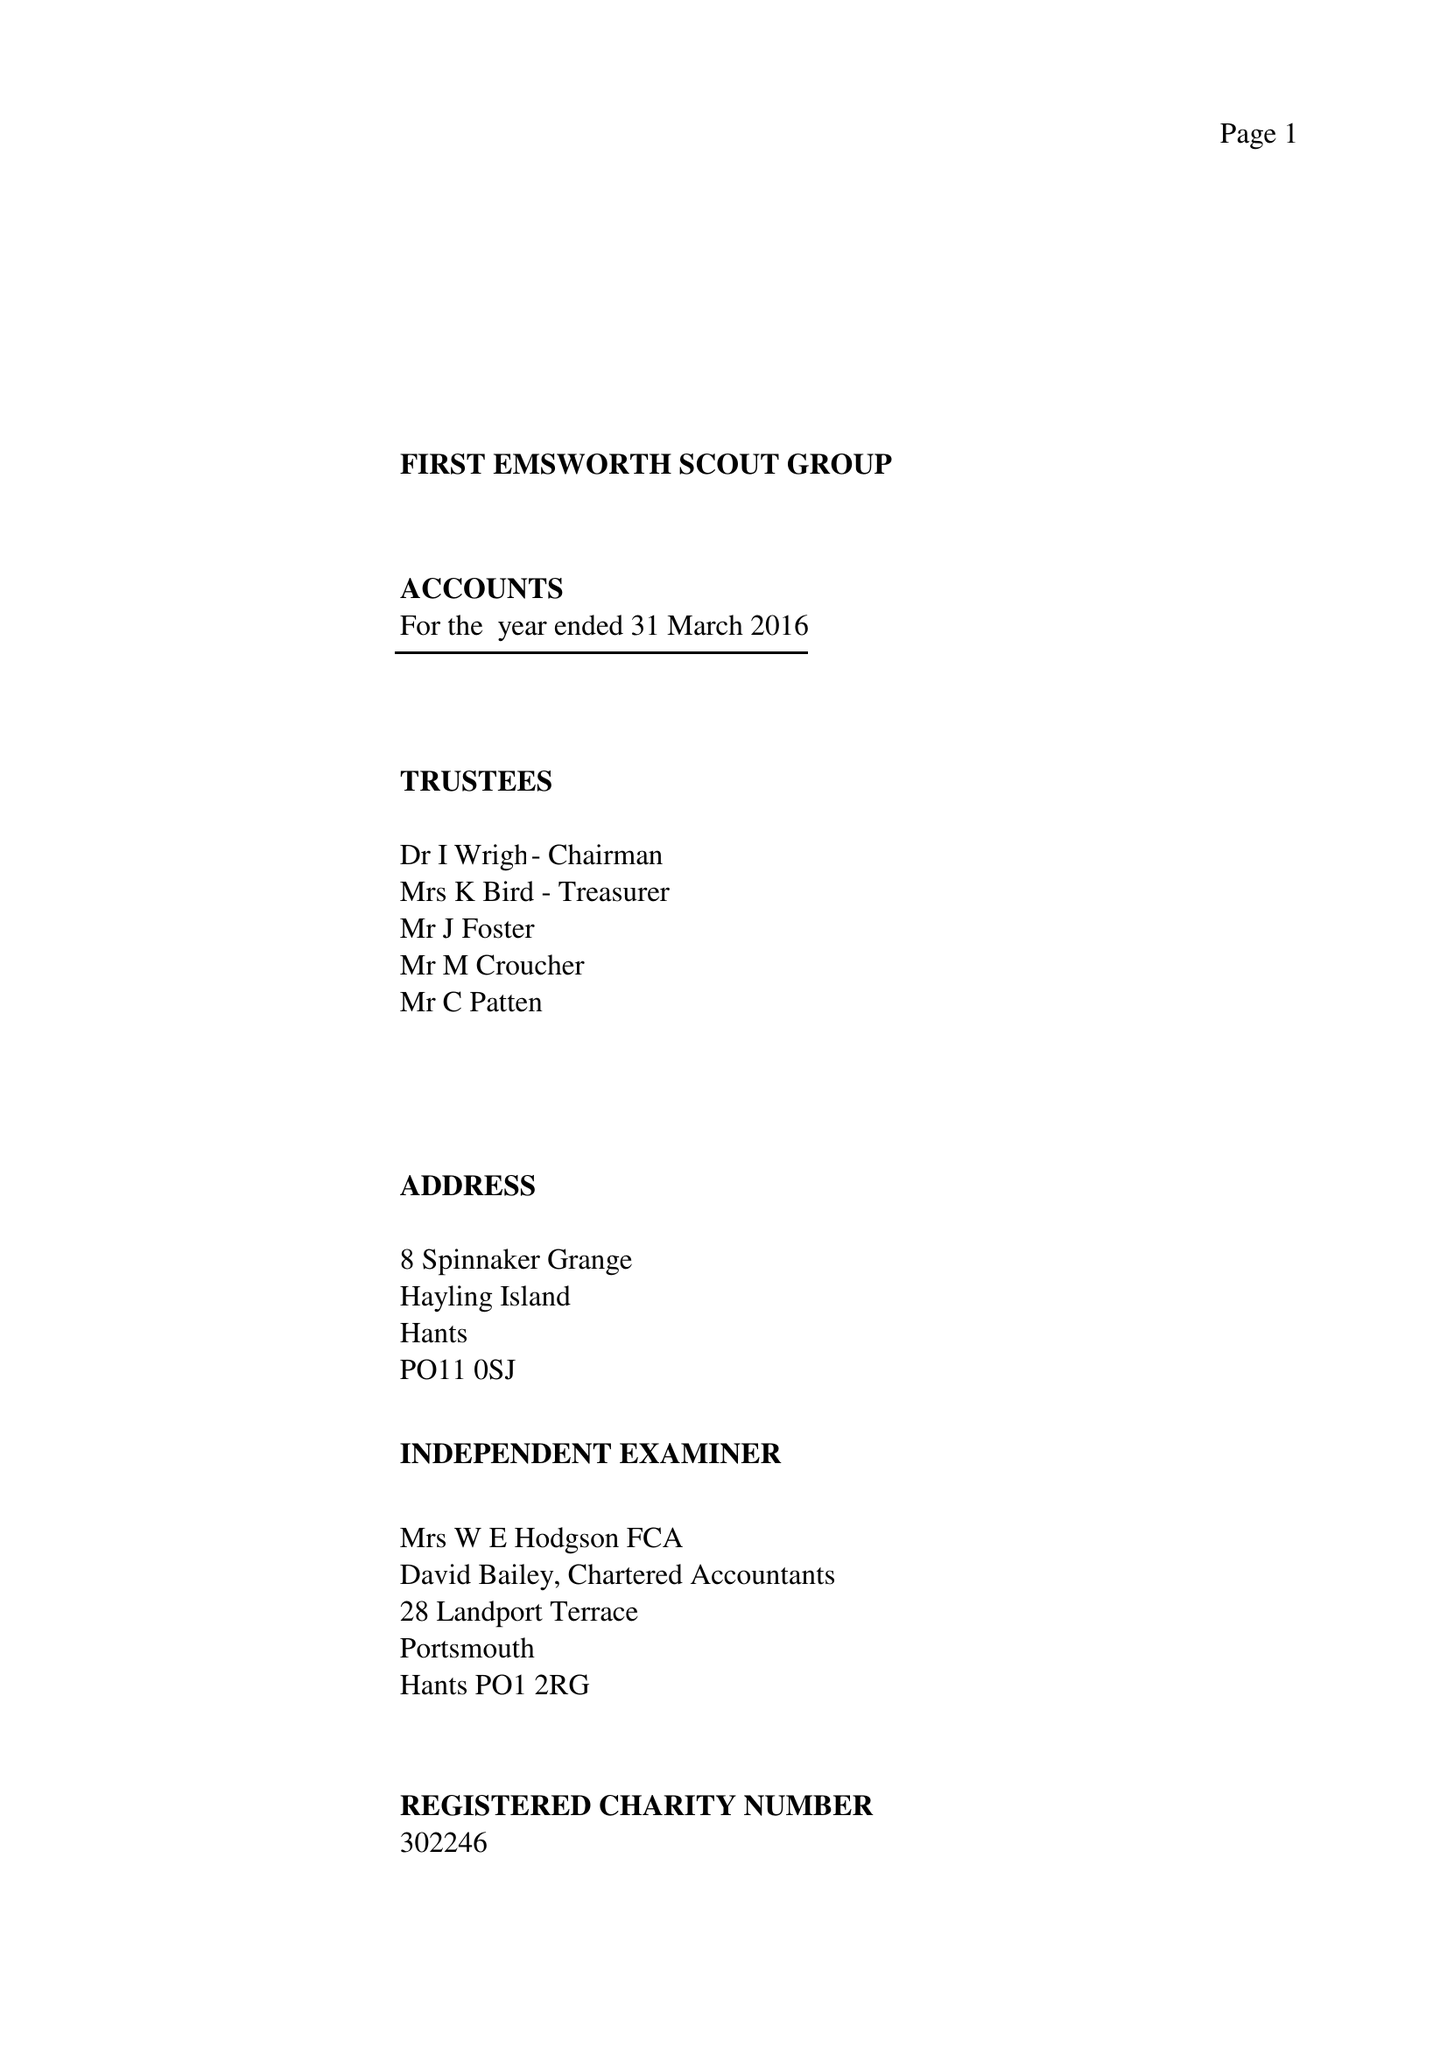What is the value for the charity_number?
Answer the question using a single word or phrase. 302246 